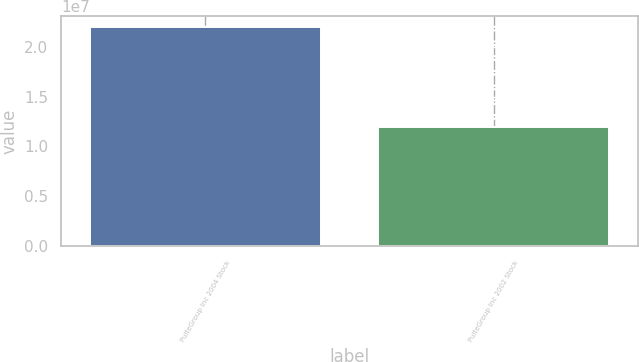Convert chart. <chart><loc_0><loc_0><loc_500><loc_500><bar_chart><fcel>PulteGroup Inc 2004 Stock<fcel>PulteGroup Inc 2002 Stock<nl><fcel>2.2e+07<fcel>1.2e+07<nl></chart> 